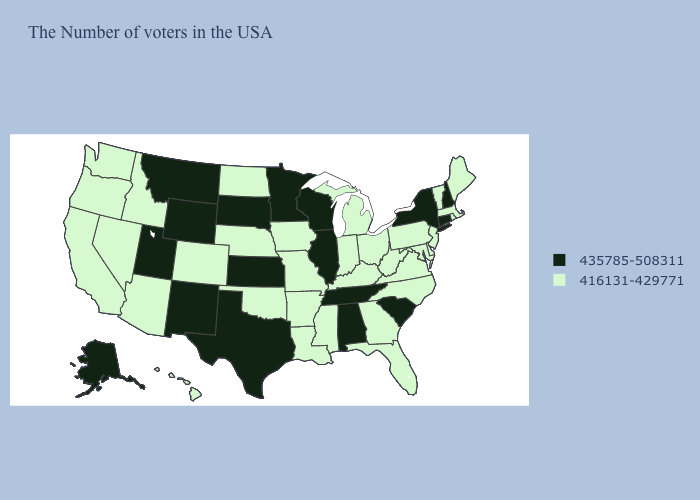What is the value of Indiana?
Be succinct. 416131-429771. Among the states that border New York , does Connecticut have the highest value?
Be succinct. Yes. What is the highest value in the Northeast ?
Write a very short answer. 435785-508311. What is the lowest value in the USA?
Concise answer only. 416131-429771. Name the states that have a value in the range 416131-429771?
Quick response, please. Maine, Massachusetts, Rhode Island, Vermont, New Jersey, Delaware, Maryland, Pennsylvania, Virginia, North Carolina, West Virginia, Ohio, Florida, Georgia, Michigan, Kentucky, Indiana, Mississippi, Louisiana, Missouri, Arkansas, Iowa, Nebraska, Oklahoma, North Dakota, Colorado, Arizona, Idaho, Nevada, California, Washington, Oregon, Hawaii. What is the lowest value in the Northeast?
Write a very short answer. 416131-429771. Name the states that have a value in the range 435785-508311?
Keep it brief. New Hampshire, Connecticut, New York, South Carolina, Alabama, Tennessee, Wisconsin, Illinois, Minnesota, Kansas, Texas, South Dakota, Wyoming, New Mexico, Utah, Montana, Alaska. How many symbols are there in the legend?
Short answer required. 2. Is the legend a continuous bar?
Give a very brief answer. No. Is the legend a continuous bar?
Concise answer only. No. What is the value of Mississippi?
Give a very brief answer. 416131-429771. Name the states that have a value in the range 435785-508311?
Answer briefly. New Hampshire, Connecticut, New York, South Carolina, Alabama, Tennessee, Wisconsin, Illinois, Minnesota, Kansas, Texas, South Dakota, Wyoming, New Mexico, Utah, Montana, Alaska. Does Alabama have a higher value than Vermont?
Concise answer only. Yes. What is the value of Connecticut?
Keep it brief. 435785-508311. How many symbols are there in the legend?
Write a very short answer. 2. 